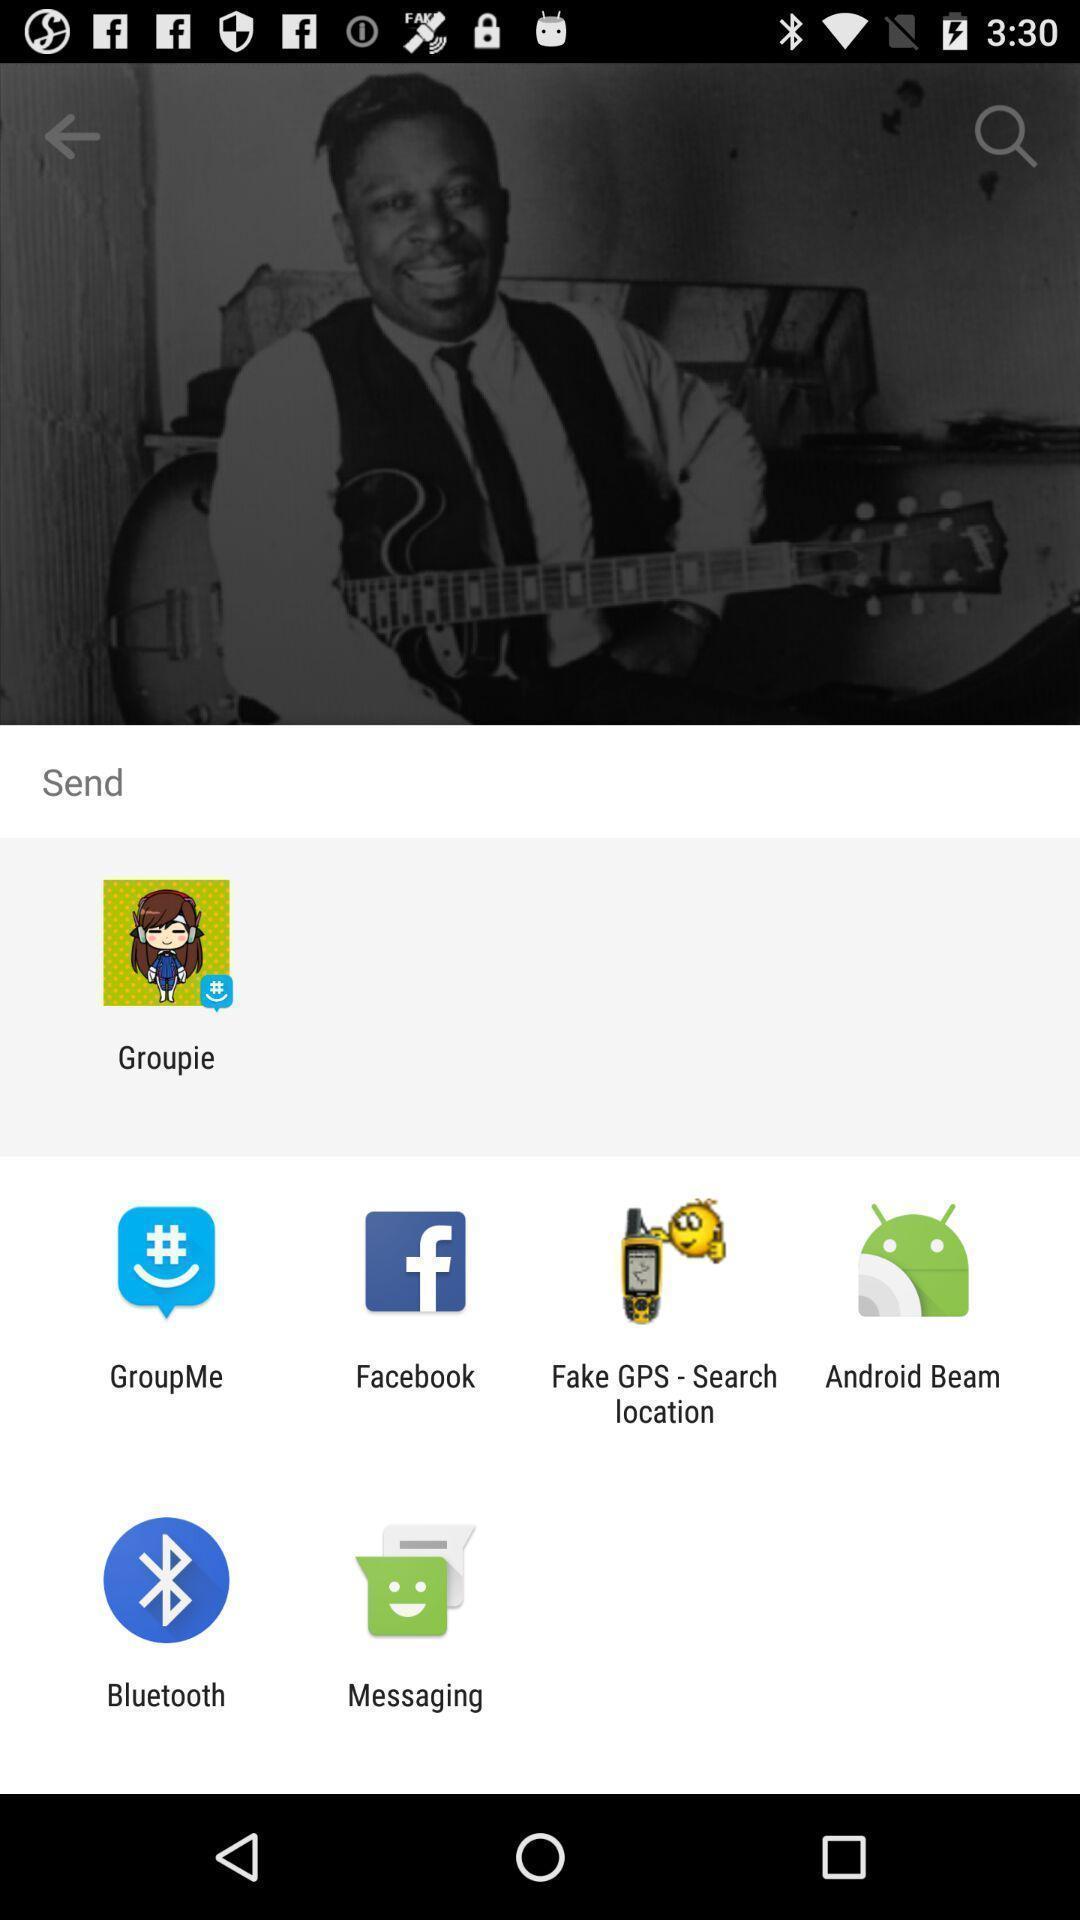Provide a description of this screenshot. Pull up screen of share option. 